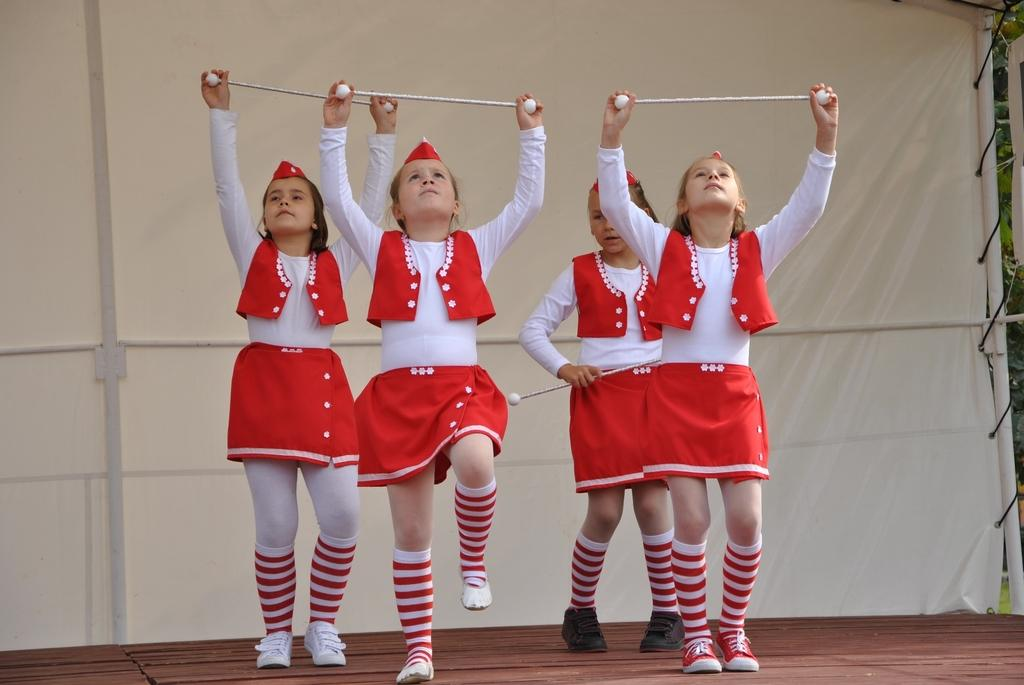How many girls are in the image? There are four girls in the image. What are the girls wearing on their heads? The girls are wearing caps. What are the girls holding in their hands? The girls are holding sticks. Where are the girls performing? The girls are performing on a stage. What can be seen in the background behind the girls? There is a white cloth with poles in the background. How does the quince affect the performance of the girls in the image? There is no mention of a quince in the image, so it cannot affect the performance of the girls. 